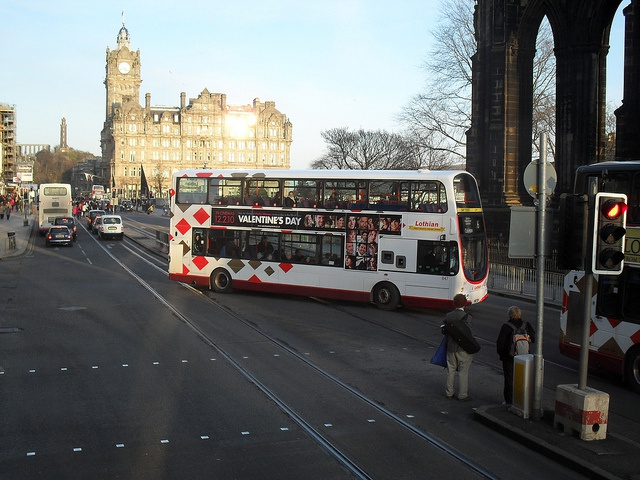Describe the objects in this image and their specific colors. I can see bus in lightblue, black, darkgray, gray, and lightgray tones, bus in lightblue, black, gray, darkgreen, and maroon tones, traffic light in lightblue, black, maroon, darkgray, and gray tones, bus in lightblue, darkgray, gray, and tan tones, and people in lightblue, gray, black, and maroon tones in this image. 